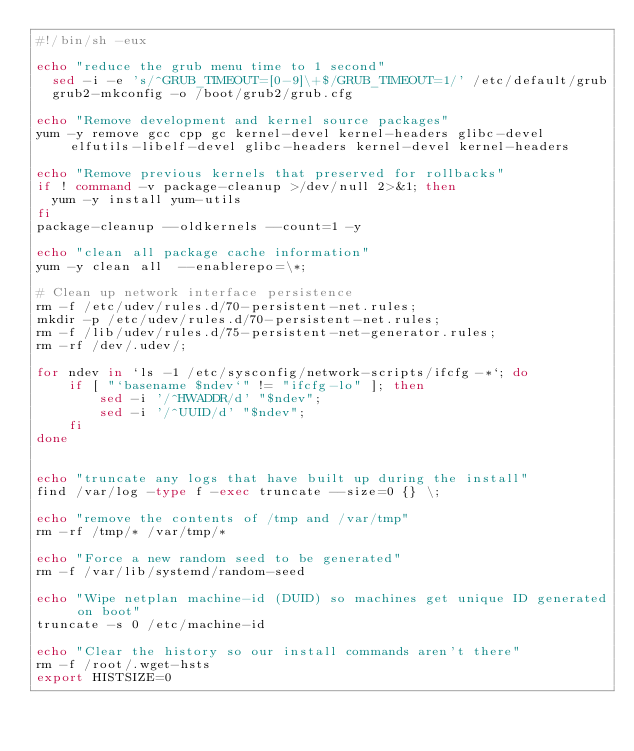Convert code to text. <code><loc_0><loc_0><loc_500><loc_500><_Bash_>#!/bin/sh -eux

echo "reduce the grub menu time to 1 second"
  sed -i -e 's/^GRUB_TIMEOUT=[0-9]\+$/GRUB_TIMEOUT=1/' /etc/default/grub
  grub2-mkconfig -o /boot/grub2/grub.cfg

echo "Remove development and kernel source packages"
yum -y remove gcc cpp gc kernel-devel kernel-headers glibc-devel elfutils-libelf-devel glibc-headers kernel-devel kernel-headers

echo "Remove previous kernels that preserved for rollbacks"
if ! command -v package-cleanup >/dev/null 2>&1; then
  yum -y install yum-utils
fi
package-cleanup --oldkernels --count=1 -y

echo "clean all package cache information"
yum -y clean all  --enablerepo=\*;

# Clean up network interface persistence
rm -f /etc/udev/rules.d/70-persistent-net.rules;
mkdir -p /etc/udev/rules.d/70-persistent-net.rules;
rm -f /lib/udev/rules.d/75-persistent-net-generator.rules;
rm -rf /dev/.udev/;

for ndev in `ls -1 /etc/sysconfig/network-scripts/ifcfg-*`; do
    if [ "`basename $ndev`" != "ifcfg-lo" ]; then
        sed -i '/^HWADDR/d' "$ndev";
        sed -i '/^UUID/d' "$ndev";
    fi
done


echo "truncate any logs that have built up during the install"
find /var/log -type f -exec truncate --size=0 {} \;

echo "remove the contents of /tmp and /var/tmp"
rm -rf /tmp/* /var/tmp/*

echo "Force a new random seed to be generated"
rm -f /var/lib/systemd/random-seed

echo "Wipe netplan machine-id (DUID) so machines get unique ID generated on boot"
truncate -s 0 /etc/machine-id

echo "Clear the history so our install commands aren't there"
rm -f /root/.wget-hsts
export HISTSIZE=0</code> 